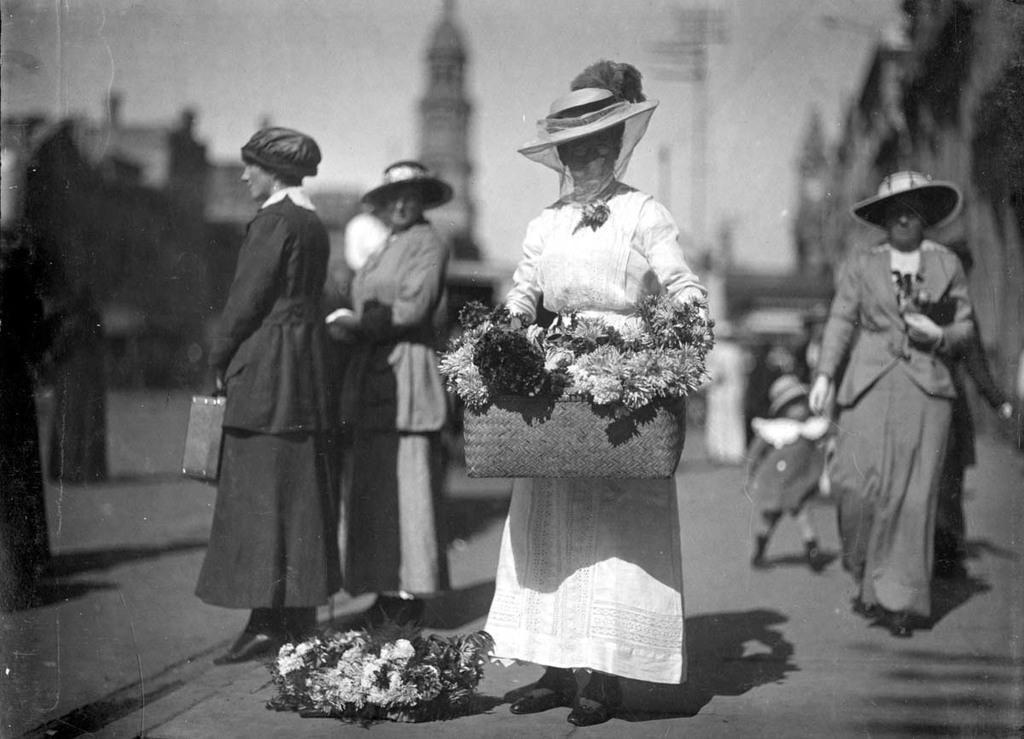Can you describe this image briefly? This is a black and white image. In this image there are few persons standing on the road and holding some objects. In the foreground of the image there is a person standing and holding a flower basket. In the background there are some buildings and sky. 